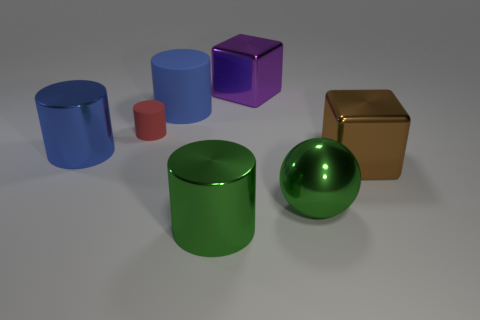There is a sphere to the left of the brown metal cube; how big is it?
Your answer should be compact. Large. What number of green things are the same size as the blue metal cylinder?
Your answer should be compact. 2. There is a large object that is the same color as the large sphere; what is its shape?
Your response must be concise. Cylinder. What material is the object that is to the left of the small red cylinder?
Provide a short and direct response. Metal. What number of purple objects have the same shape as the large brown shiny object?
Your response must be concise. 1. What is the shape of the large blue object that is made of the same material as the tiny red cylinder?
Make the answer very short. Cylinder. What shape is the small matte object that is behind the blue cylinder in front of the big blue cylinder that is on the right side of the small object?
Ensure brevity in your answer.  Cylinder. Is the number of small matte objects greater than the number of shiny things?
Your answer should be compact. No. What material is the other big thing that is the same shape as the large purple thing?
Make the answer very short. Metal. Is the big purple cube made of the same material as the tiny thing?
Make the answer very short. No. 